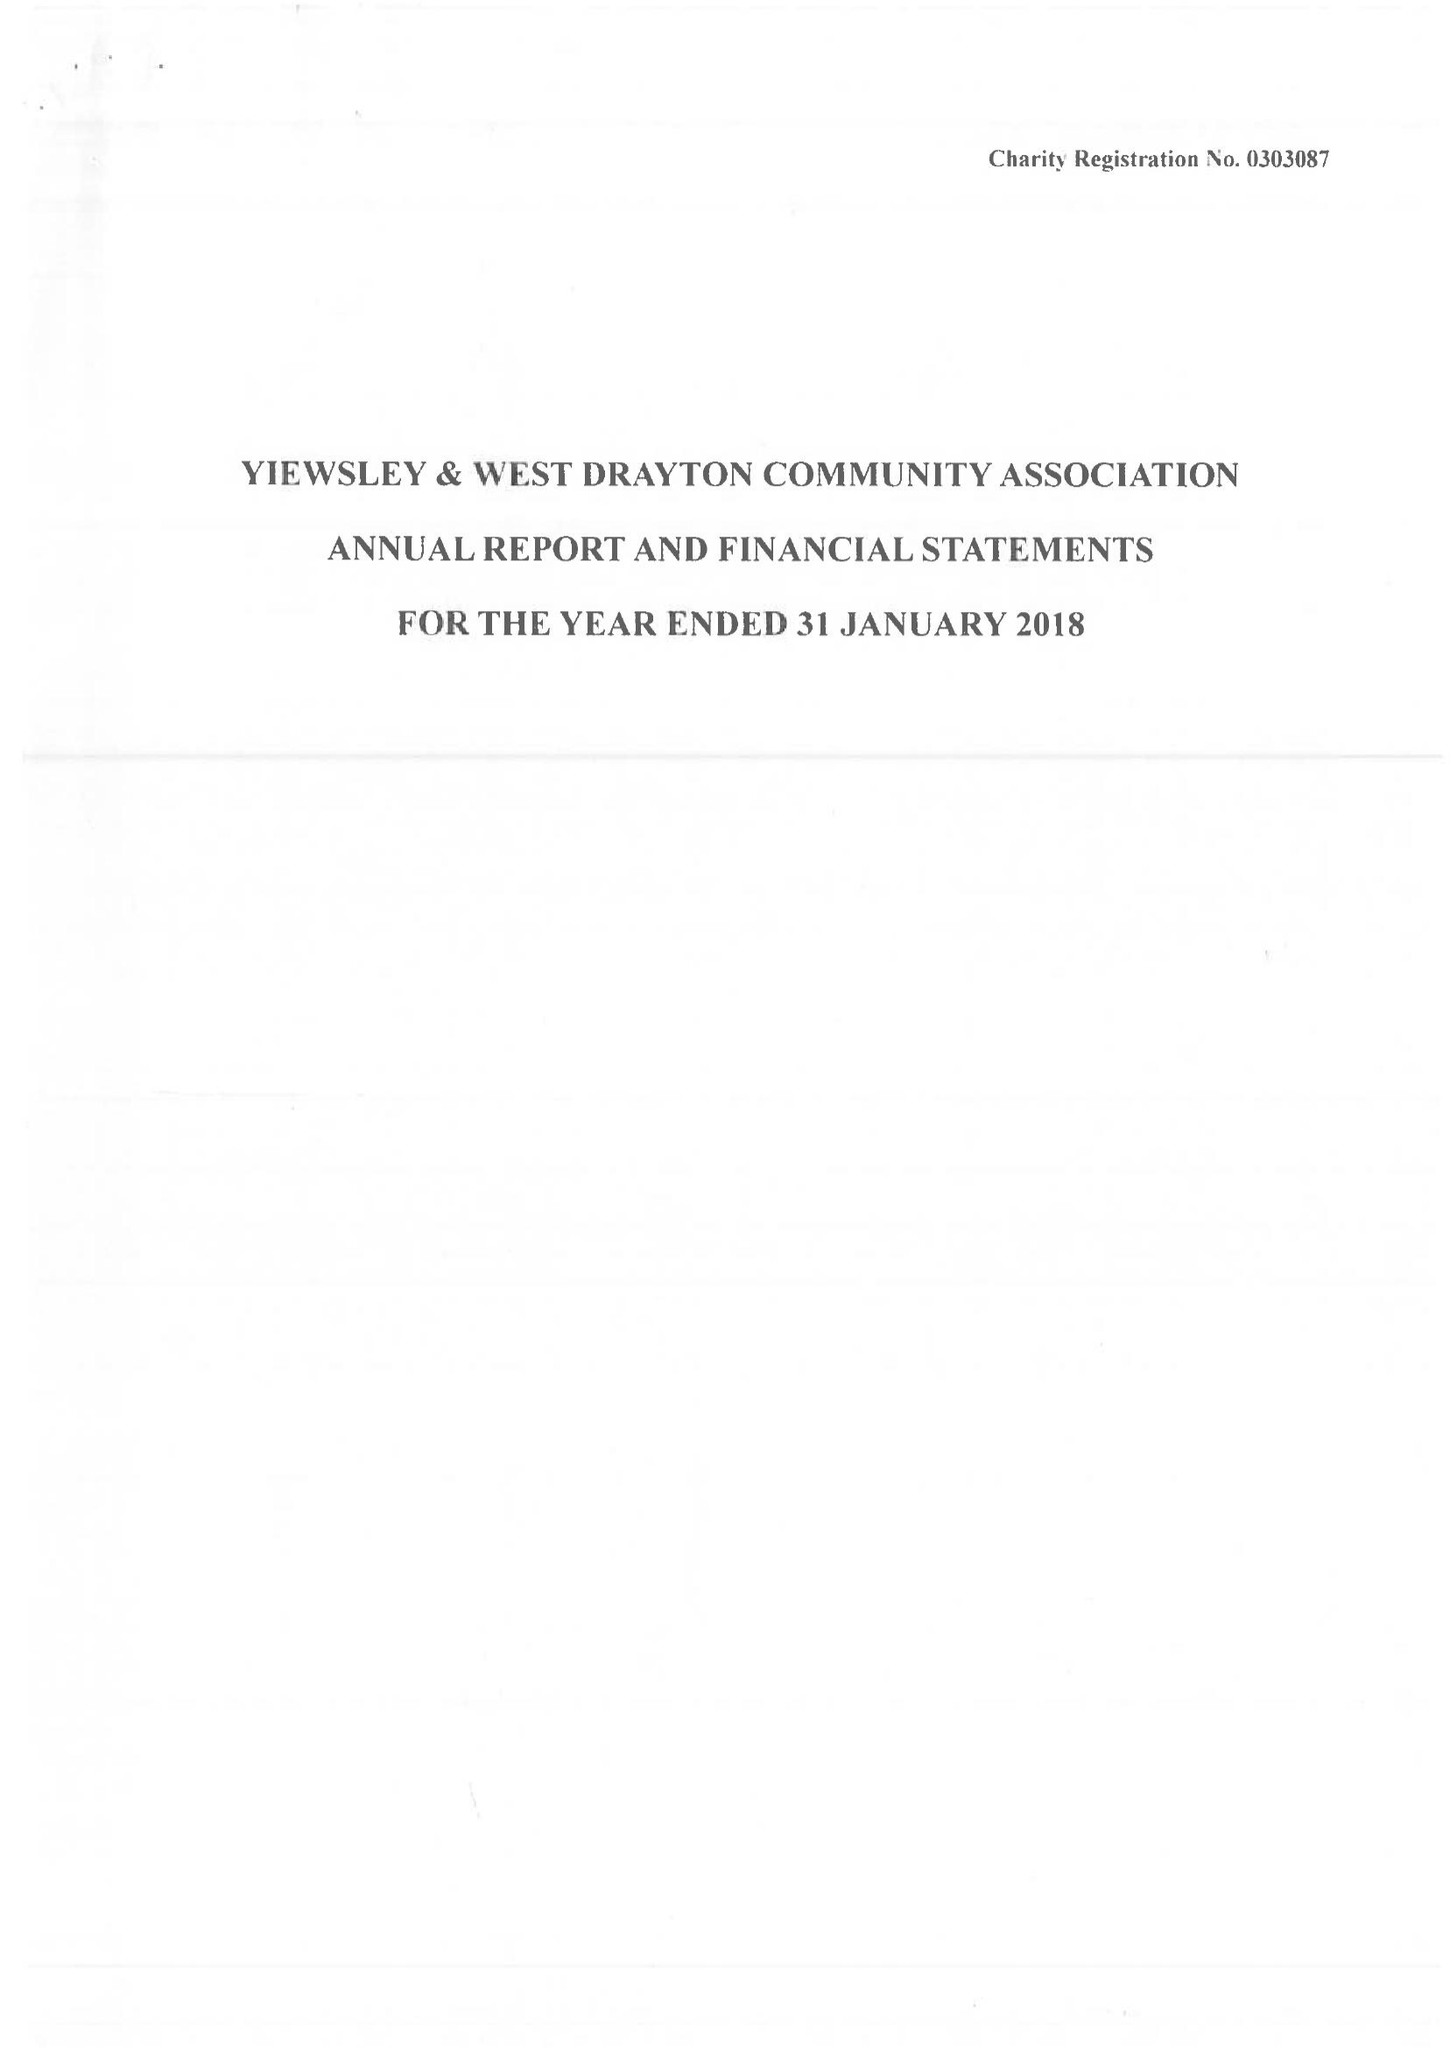What is the value for the income_annually_in_british_pounds?
Answer the question using a single word or phrase. 149834.00 